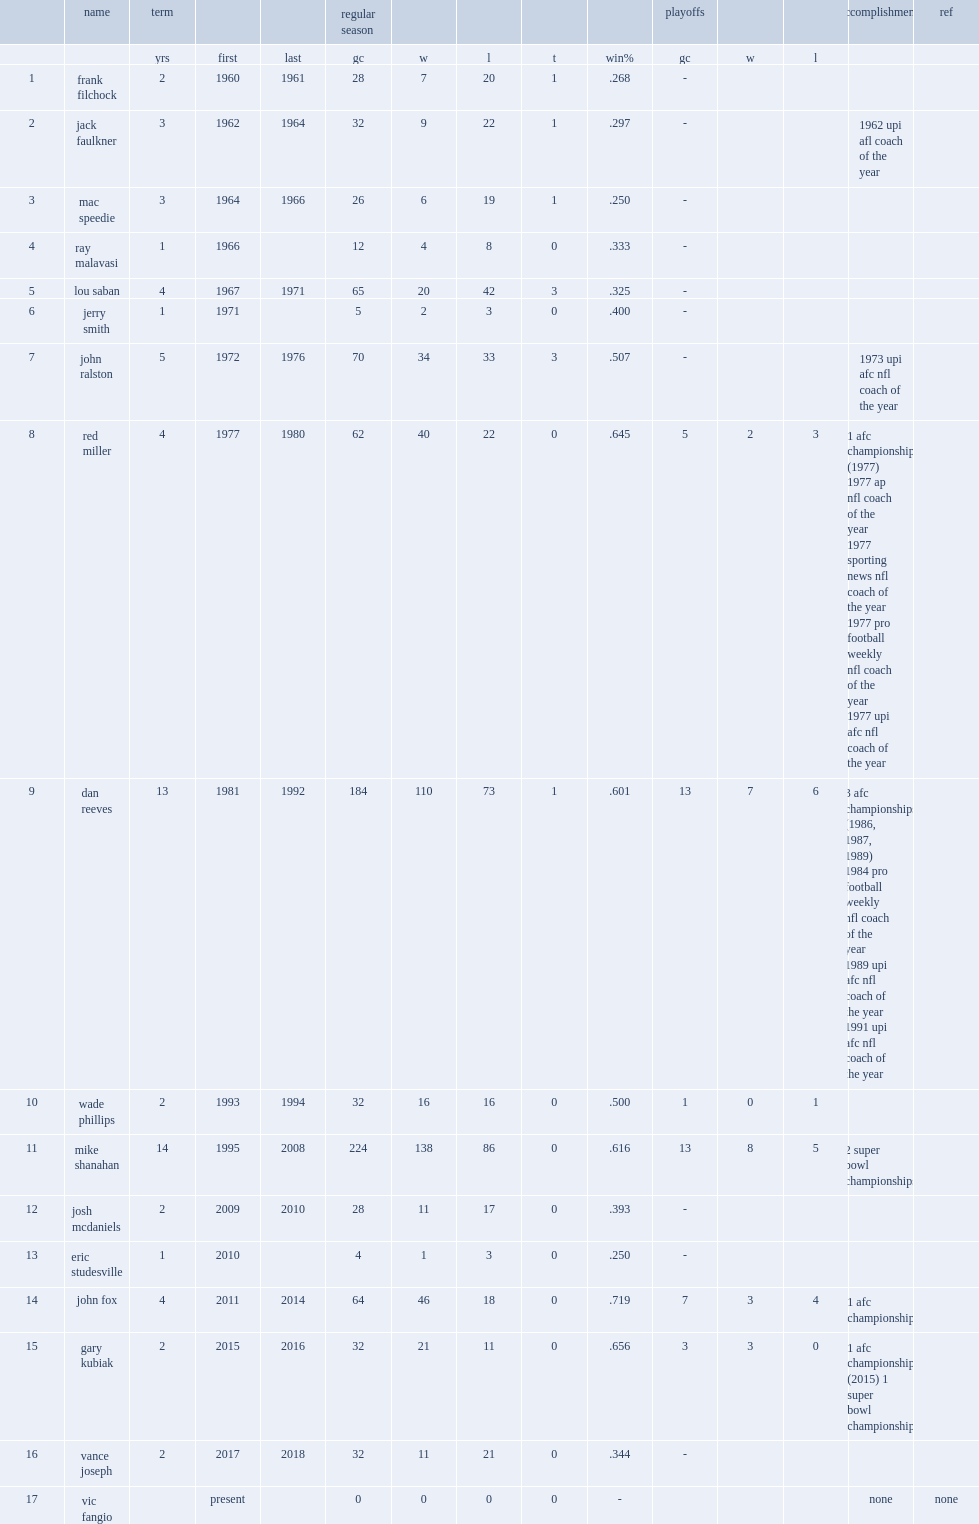Who was broncos' head coach? Mike shanahan. 